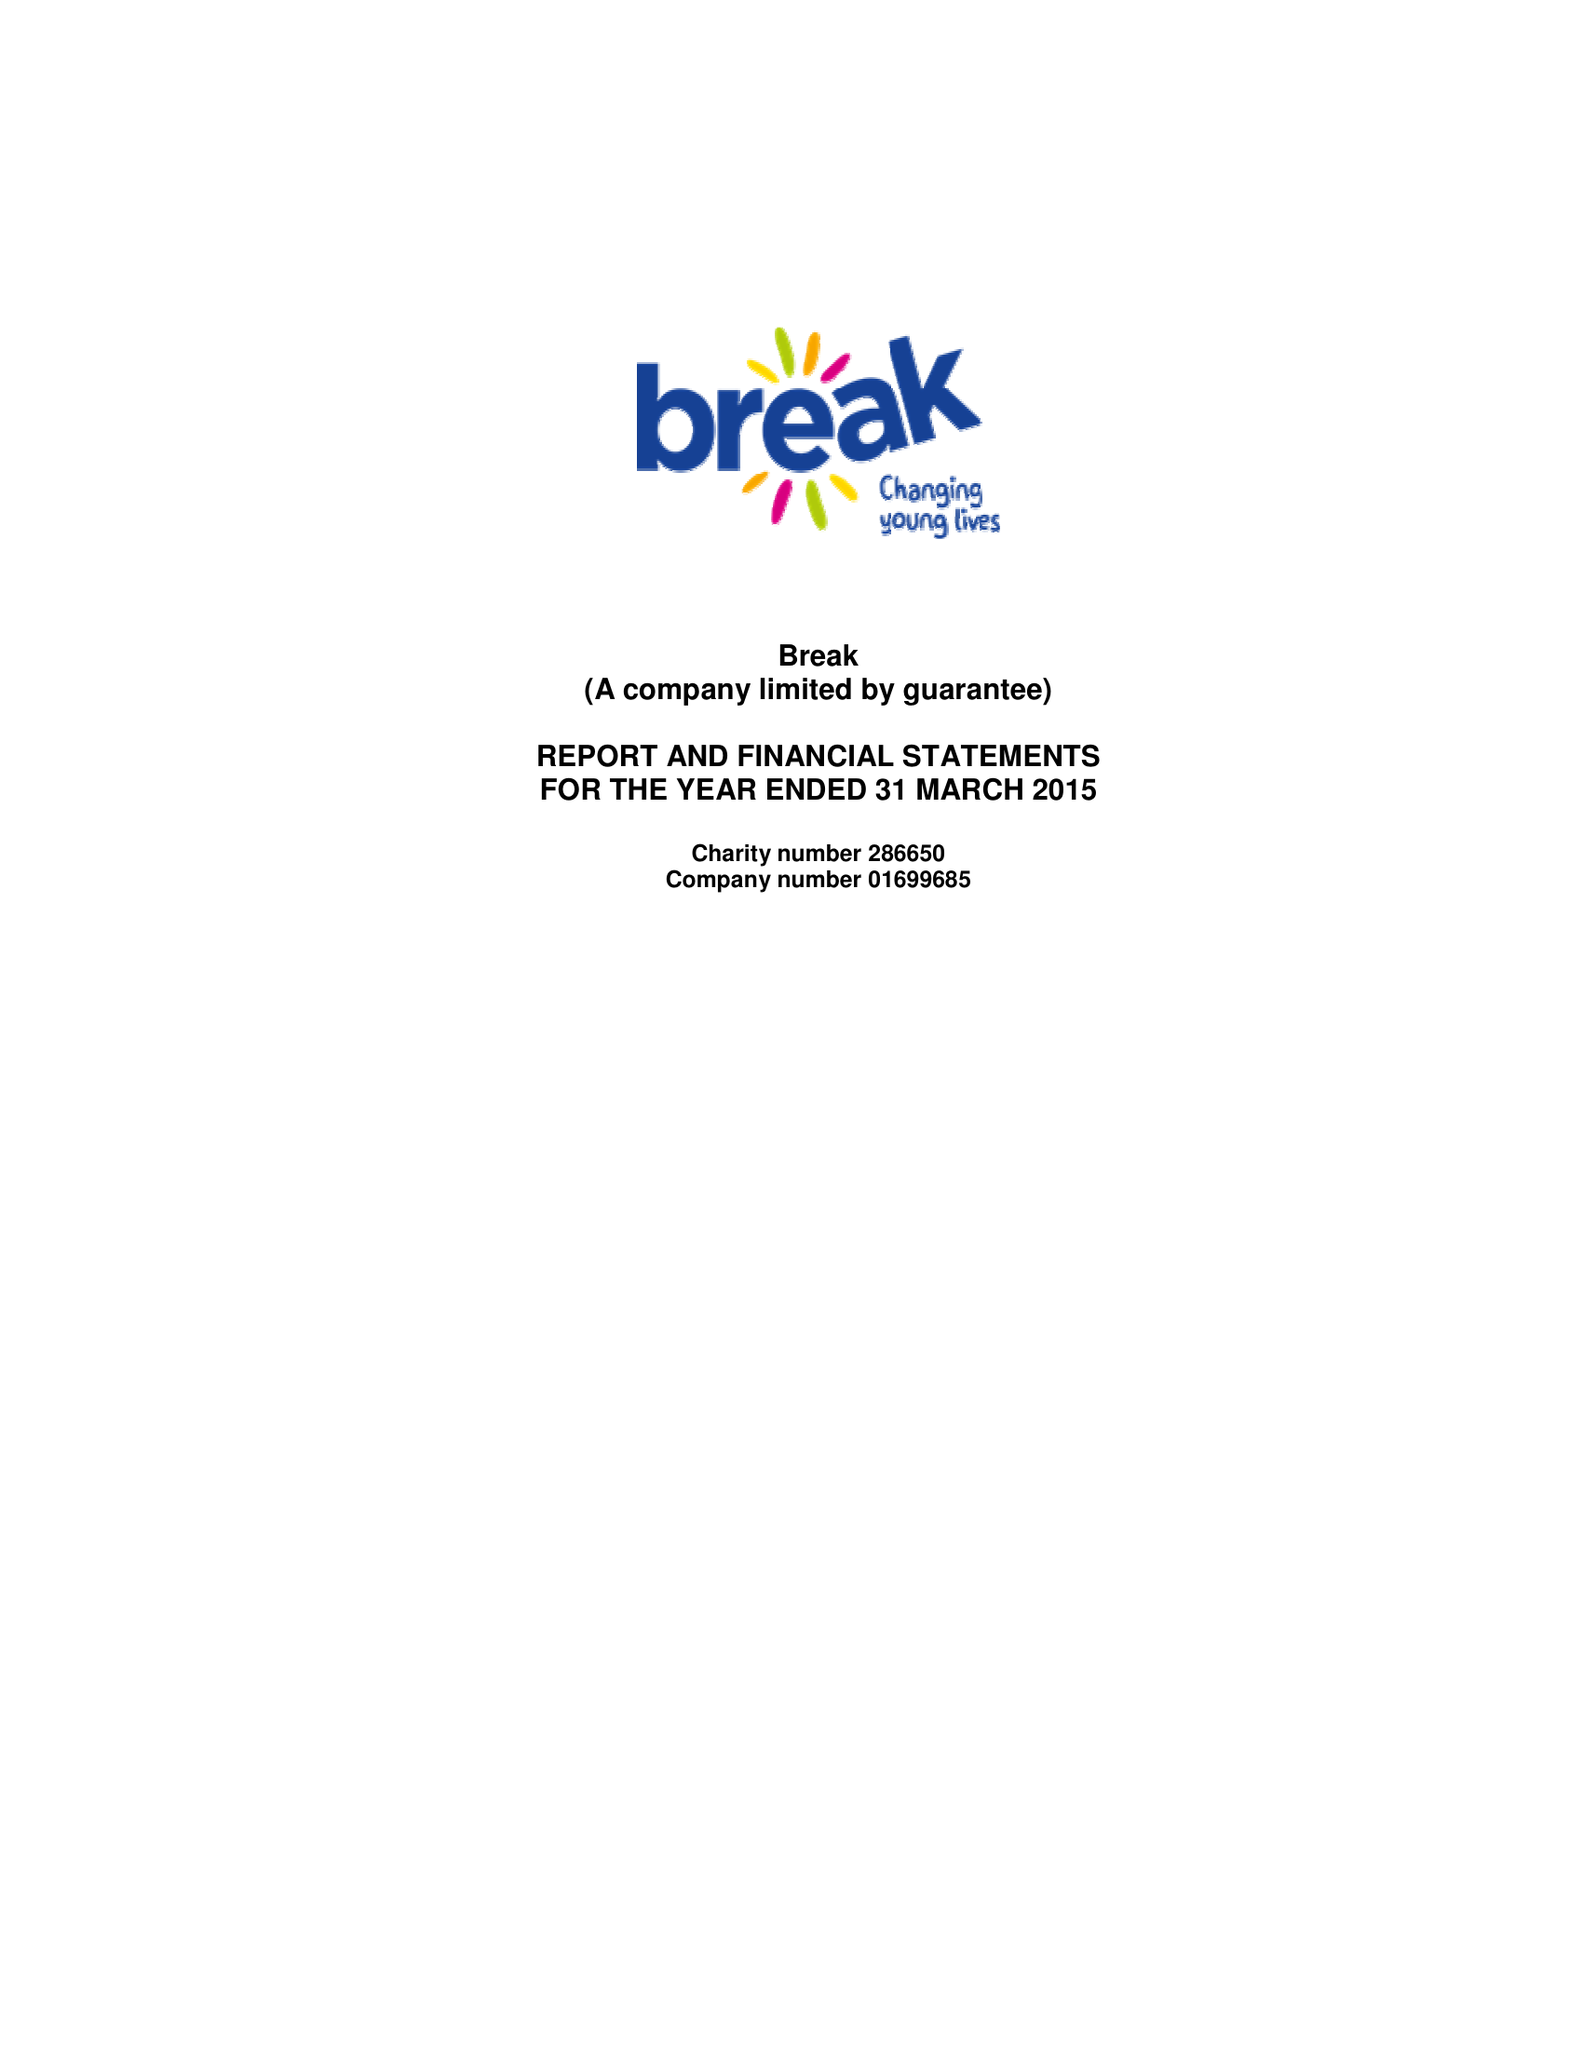What is the value for the income_annually_in_british_pounds?
Answer the question using a single word or phrase. 10037966.00 